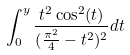Convert formula to latex. <formula><loc_0><loc_0><loc_500><loc_500>\int _ { 0 } ^ { y } \frac { t ^ { 2 } \cos ^ { 2 } ( t ) } { ( \frac { \pi ^ { 2 } } { 4 } - t ^ { 2 } ) ^ { 2 } } d t</formula> 